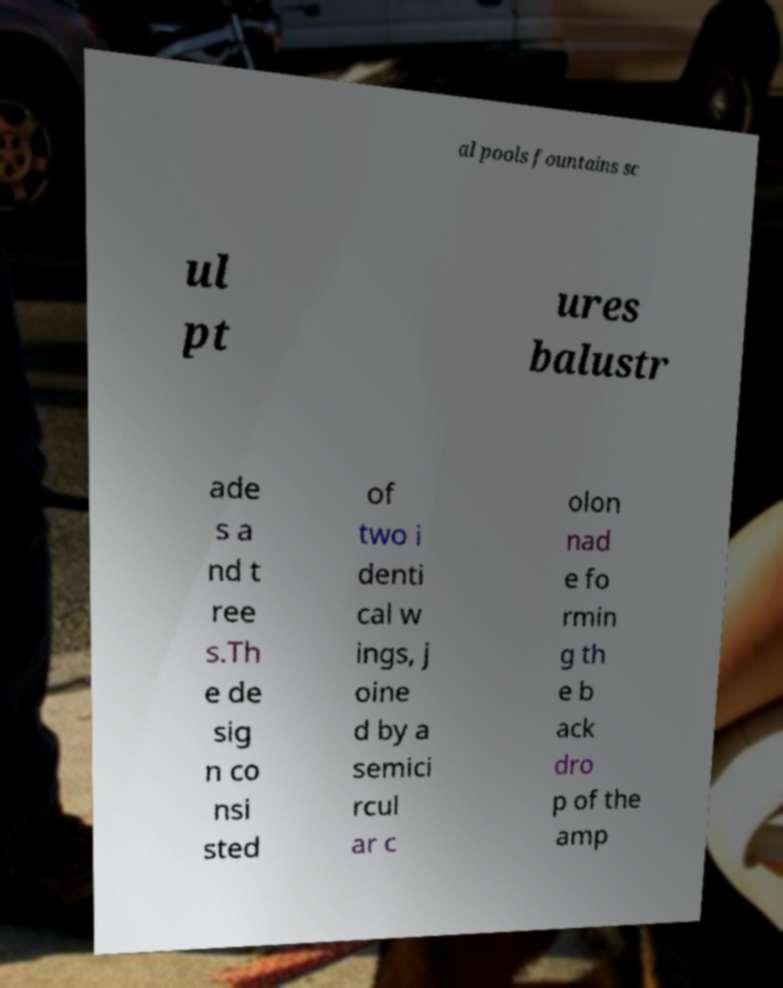What messages or text are displayed in this image? I need them in a readable, typed format. al pools fountains sc ul pt ures balustr ade s a nd t ree s.Th e de sig n co nsi sted of two i denti cal w ings, j oine d by a semici rcul ar c olon nad e fo rmin g th e b ack dro p of the amp 